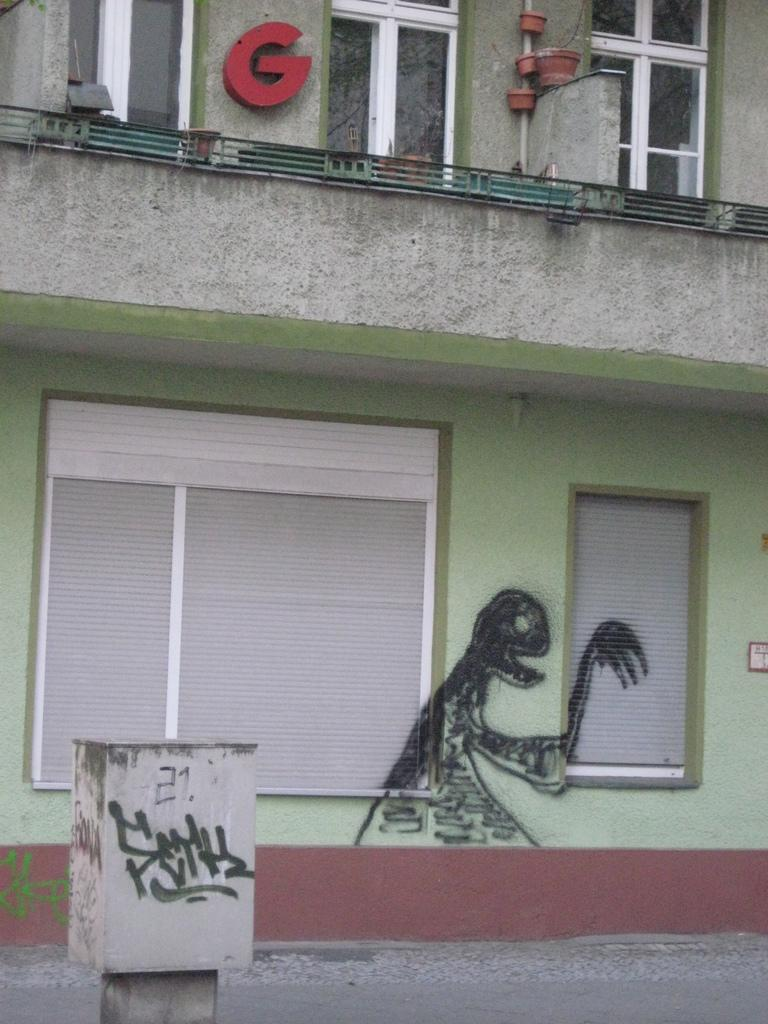What type of structure is present in the image? There is a building in the image. What features can be observed on the building? The building has windows and graffiti. Is there any additional information attached to the building? Yes, there is a letter attached to the wall. What else can be seen in the image? There is a small pillar and a road visible in the image. What type of yarn is being used to create the graffiti on the building? There is no yarn present in the image; the graffiti is likely created using paint or other materials. Can you hear a drum playing in the background of the image? There is no sound or indication of a drum in the image; it is a still photograph. 